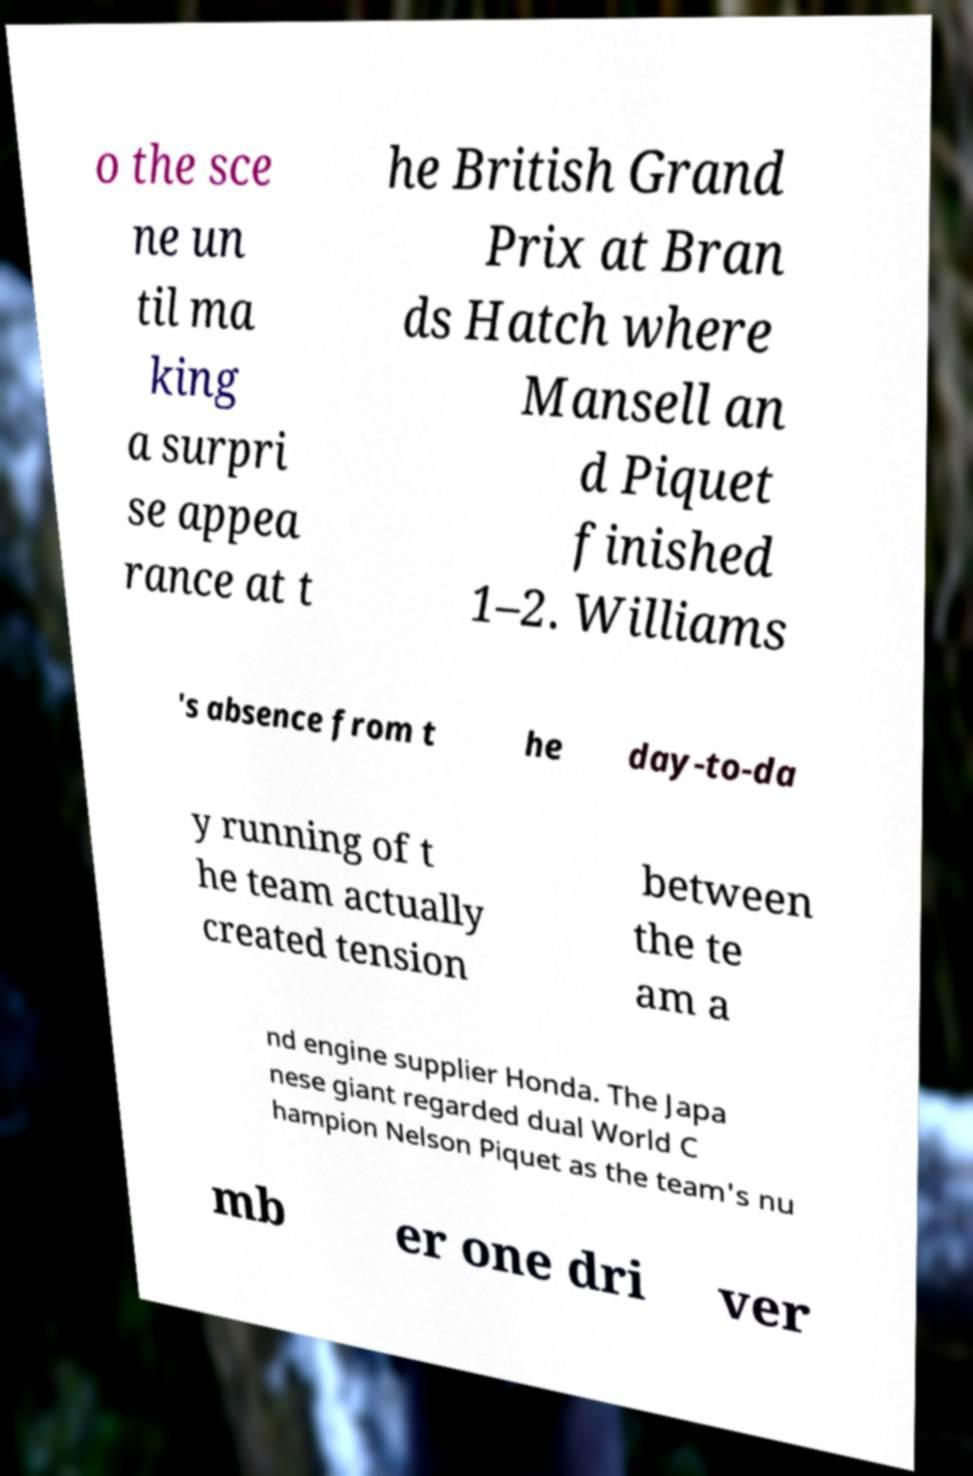Could you extract and type out the text from this image? o the sce ne un til ma king a surpri se appea rance at t he British Grand Prix at Bran ds Hatch where Mansell an d Piquet finished 1–2. Williams 's absence from t he day-to-da y running of t he team actually created tension between the te am a nd engine supplier Honda. The Japa nese giant regarded dual World C hampion Nelson Piquet as the team's nu mb er one dri ver 